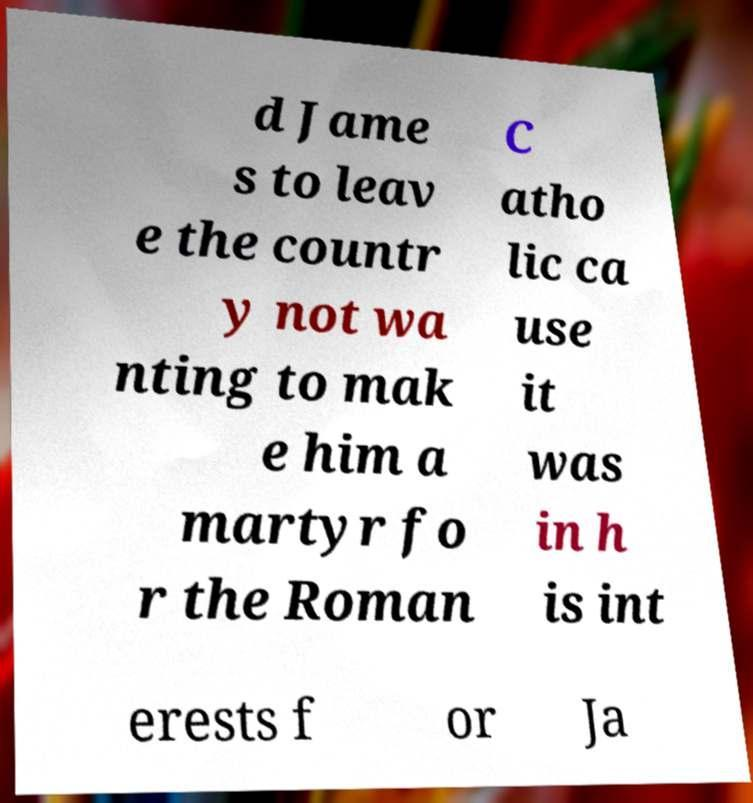For documentation purposes, I need the text within this image transcribed. Could you provide that? d Jame s to leav e the countr y not wa nting to mak e him a martyr fo r the Roman C atho lic ca use it was in h is int erests f or Ja 